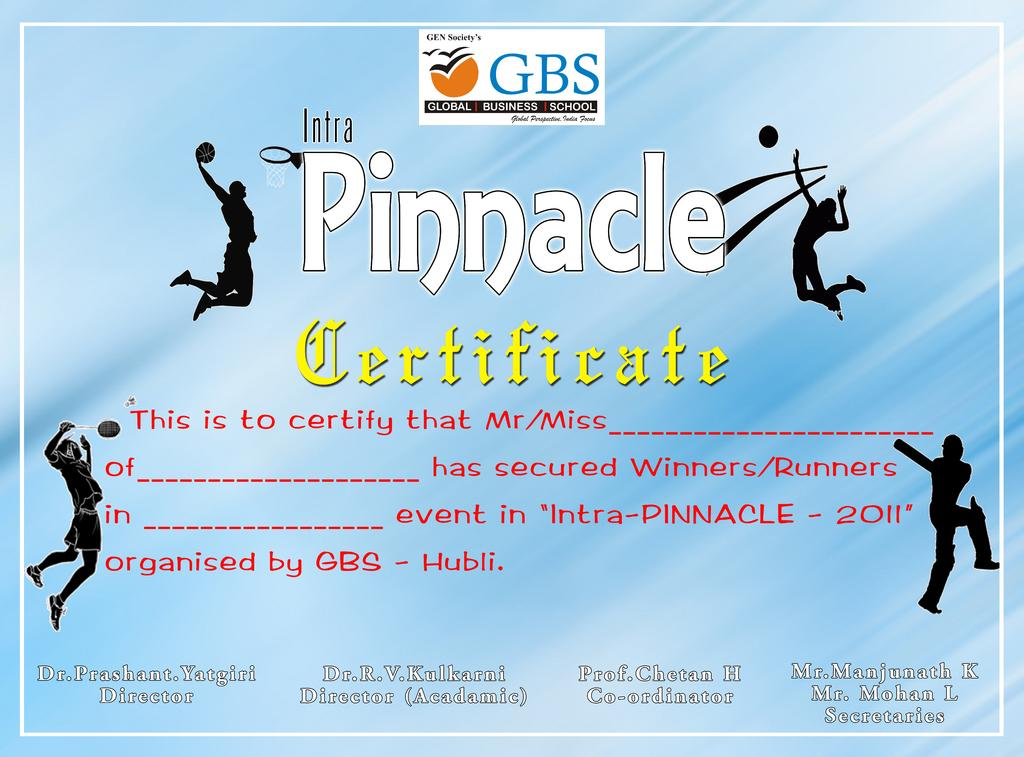<image>
Provide a brief description of the given image. a GBS poster for sports Intra Pinnacle winners 